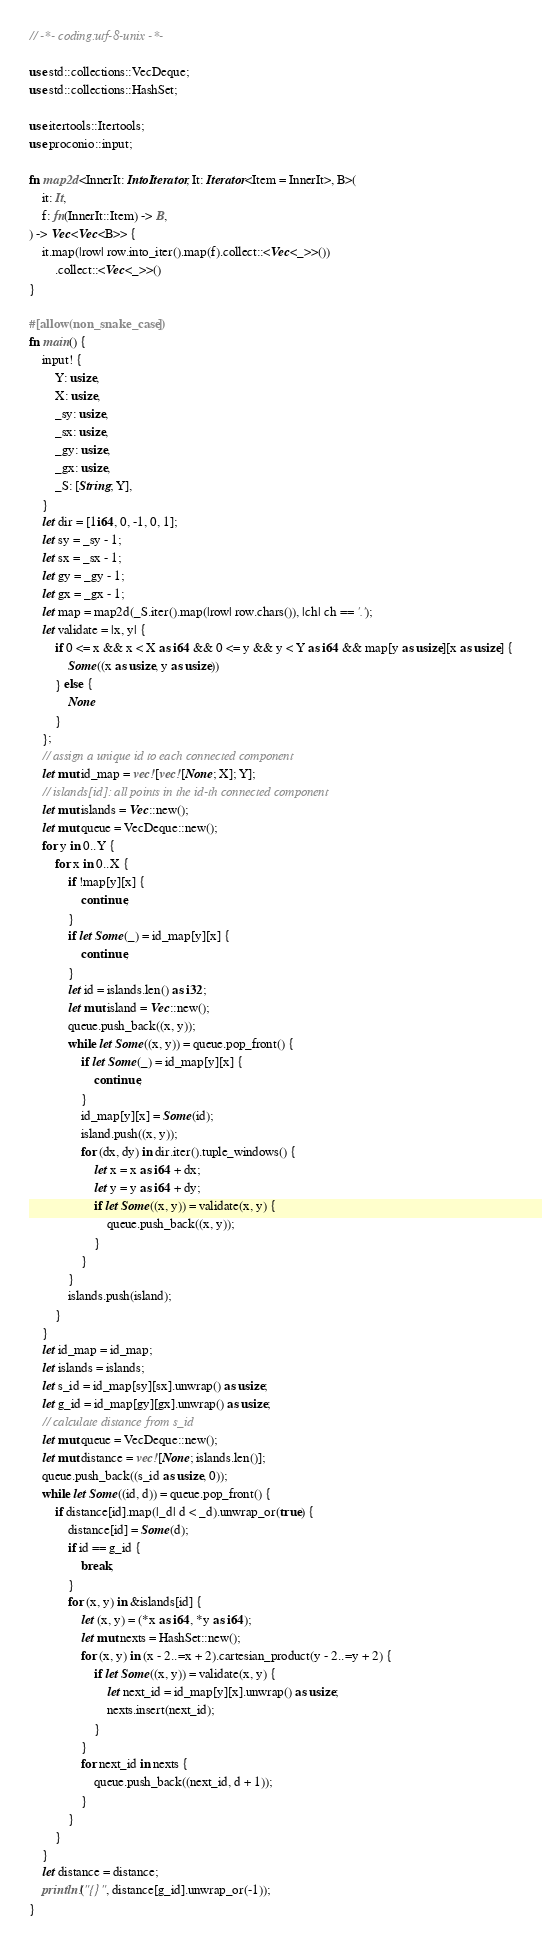Convert code to text. <code><loc_0><loc_0><loc_500><loc_500><_Rust_>// -*- coding:utf-8-unix -*-

use std::collections::VecDeque;
use std::collections::HashSet;

use itertools::Itertools;
use proconio::input;

fn map2d<InnerIt: IntoIterator, It: Iterator<Item = InnerIt>, B>(
    it: It,
    f: fn(InnerIt::Item) -> B,
) -> Vec<Vec<B>> {
    it.map(|row| row.into_iter().map(f).collect::<Vec<_>>())
        .collect::<Vec<_>>()
}

#[allow(non_snake_case)]
fn main() {
    input! {
        Y: usize,
        X: usize,
        _sy: usize,
        _sx: usize,
        _gy: usize,
        _gx: usize,
        _S: [String; Y],
    }
    let dir = [1i64, 0, -1, 0, 1];
    let sy = _sy - 1;
    let sx = _sx - 1;
    let gy = _gy - 1;
    let gx = _gx - 1;
    let map = map2d(_S.iter().map(|row| row.chars()), |ch| ch == '.');
    let validate = |x, y| {
        if 0 <= x && x < X as i64 && 0 <= y && y < Y as i64 && map[y as usize][x as usize] {
            Some((x as usize, y as usize))
        } else {
            None
        }
    };
    // assign a unique id to each connected component
    let mut id_map = vec![vec![None; X]; Y];
    // islands[id]: all points in the id-th connected component
    let mut islands = Vec::new();
    let mut queue = VecDeque::new();
    for y in 0..Y {
        for x in 0..X {
            if !map[y][x] {
                continue;
            }
            if let Some(_) = id_map[y][x] {
                continue;
            }
            let id = islands.len() as i32;
            let mut island = Vec::new();
            queue.push_back((x, y));
            while let Some((x, y)) = queue.pop_front() {
                if let Some(_) = id_map[y][x] {
                    continue;
                }
                id_map[y][x] = Some(id);
                island.push((x, y));
                for (dx, dy) in dir.iter().tuple_windows() {
                    let x = x as i64 + dx;
                    let y = y as i64 + dy;
                    if let Some((x, y)) = validate(x, y) {
                        queue.push_back((x, y));
                    }
                }
            }
            islands.push(island);
        }
    }
    let id_map = id_map;
    let islands = islands;
    let s_id = id_map[sy][sx].unwrap() as usize;
    let g_id = id_map[gy][gx].unwrap() as usize;
    // calculate distance from s_id
    let mut queue = VecDeque::new();
    let mut distance = vec![None; islands.len()];
    queue.push_back((s_id as usize, 0));
    while let Some((id, d)) = queue.pop_front() {
        if distance[id].map(|_d| d < _d).unwrap_or(true) {
            distance[id] = Some(d);
            if id == g_id {
                break;
            }
            for (x, y) in &islands[id] {
                let (x, y) = (*x as i64, *y as i64);
                let mut nexts = HashSet::new();
                for (x, y) in (x - 2..=x + 2).cartesian_product(y - 2..=y + 2) {
                    if let Some((x, y)) = validate(x, y) {
                        let next_id = id_map[y][x].unwrap() as usize;
                        nexts.insert(next_id);
                    }
                }
                for next_id in nexts {
                    queue.push_back((next_id, d + 1));
                }
            }
        }
    }
    let distance = distance;
    println!("{}", distance[g_id].unwrap_or(-1));
}
</code> 